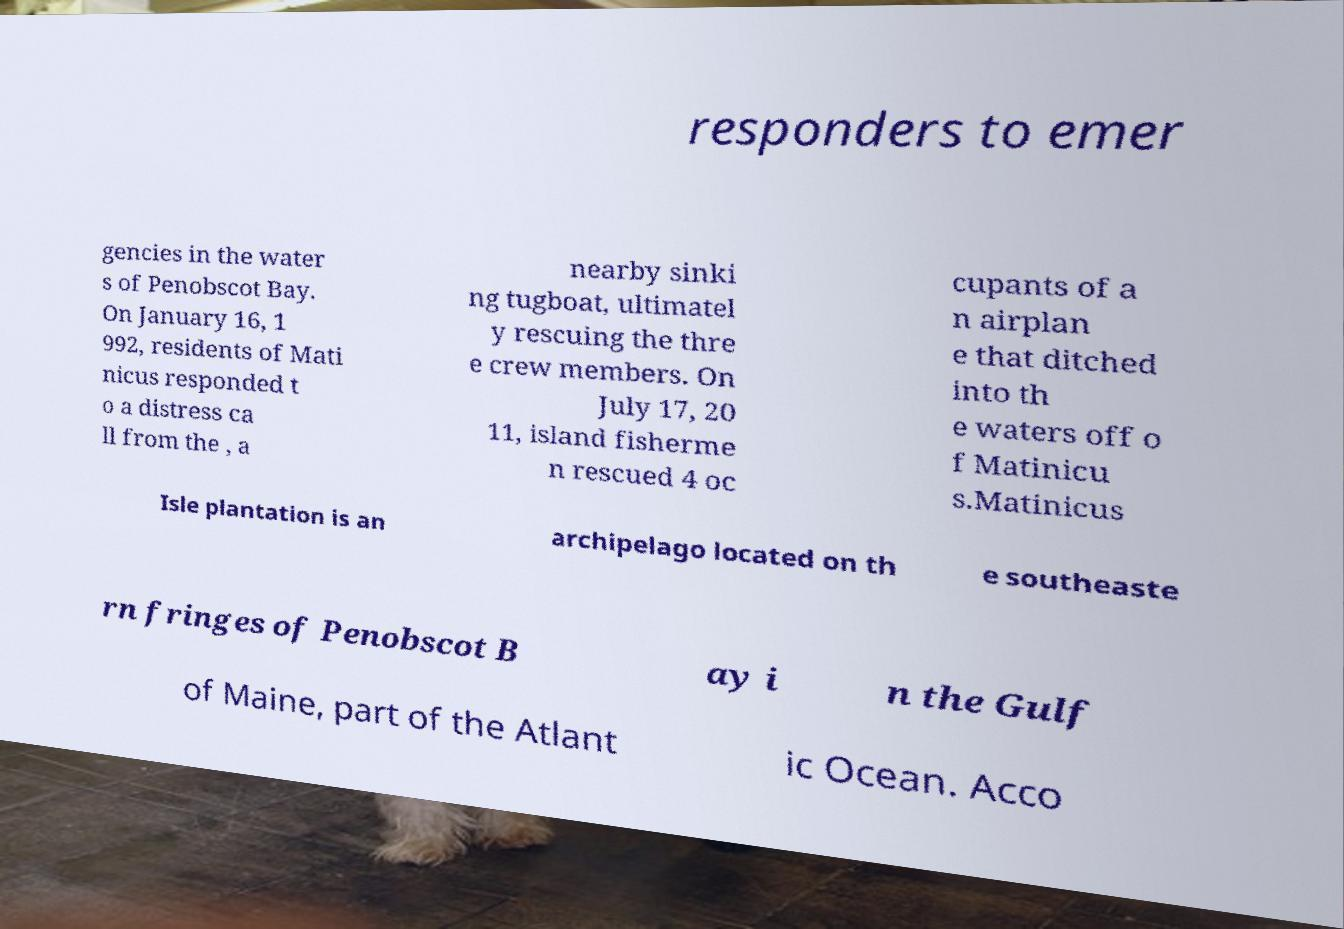There's text embedded in this image that I need extracted. Can you transcribe it verbatim? responders to emer gencies in the water s of Penobscot Bay. On January 16, 1 992, residents of Mati nicus responded t o a distress ca ll from the , a nearby sinki ng tugboat, ultimatel y rescuing the thre e crew members. On July 17, 20 11, island fisherme n rescued 4 oc cupants of a n airplan e that ditched into th e waters off o f Matinicu s.Matinicus Isle plantation is an archipelago located on th e southeaste rn fringes of Penobscot B ay i n the Gulf of Maine, part of the Atlant ic Ocean. Acco 